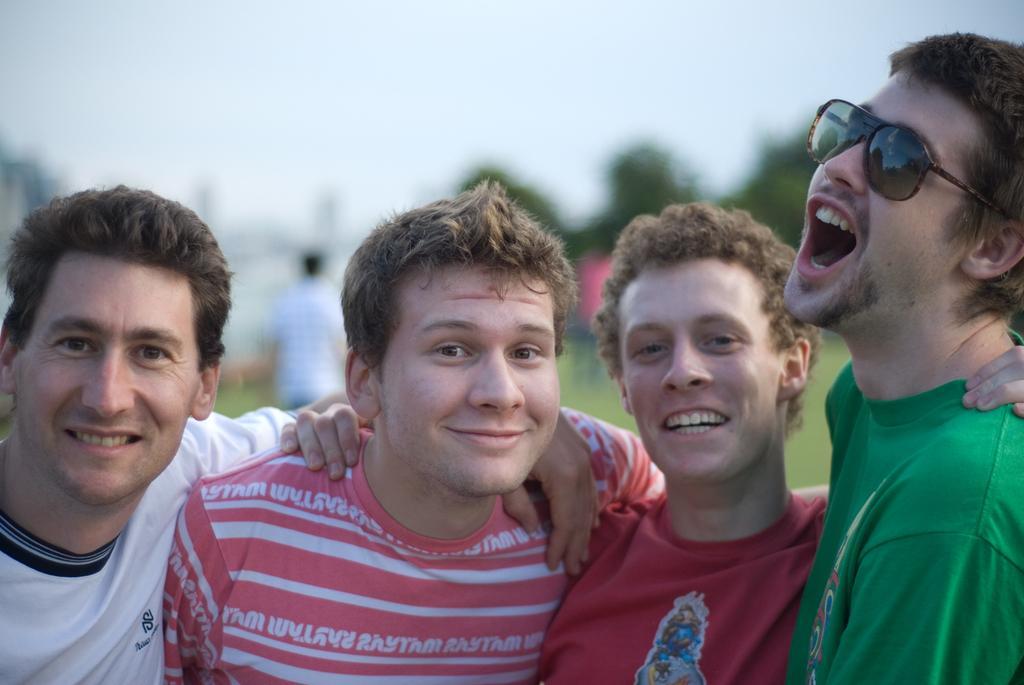Describe this image in one or two sentences. In this image we can see there are group of people standing and smiling, behind them there are so many other people and trees. 